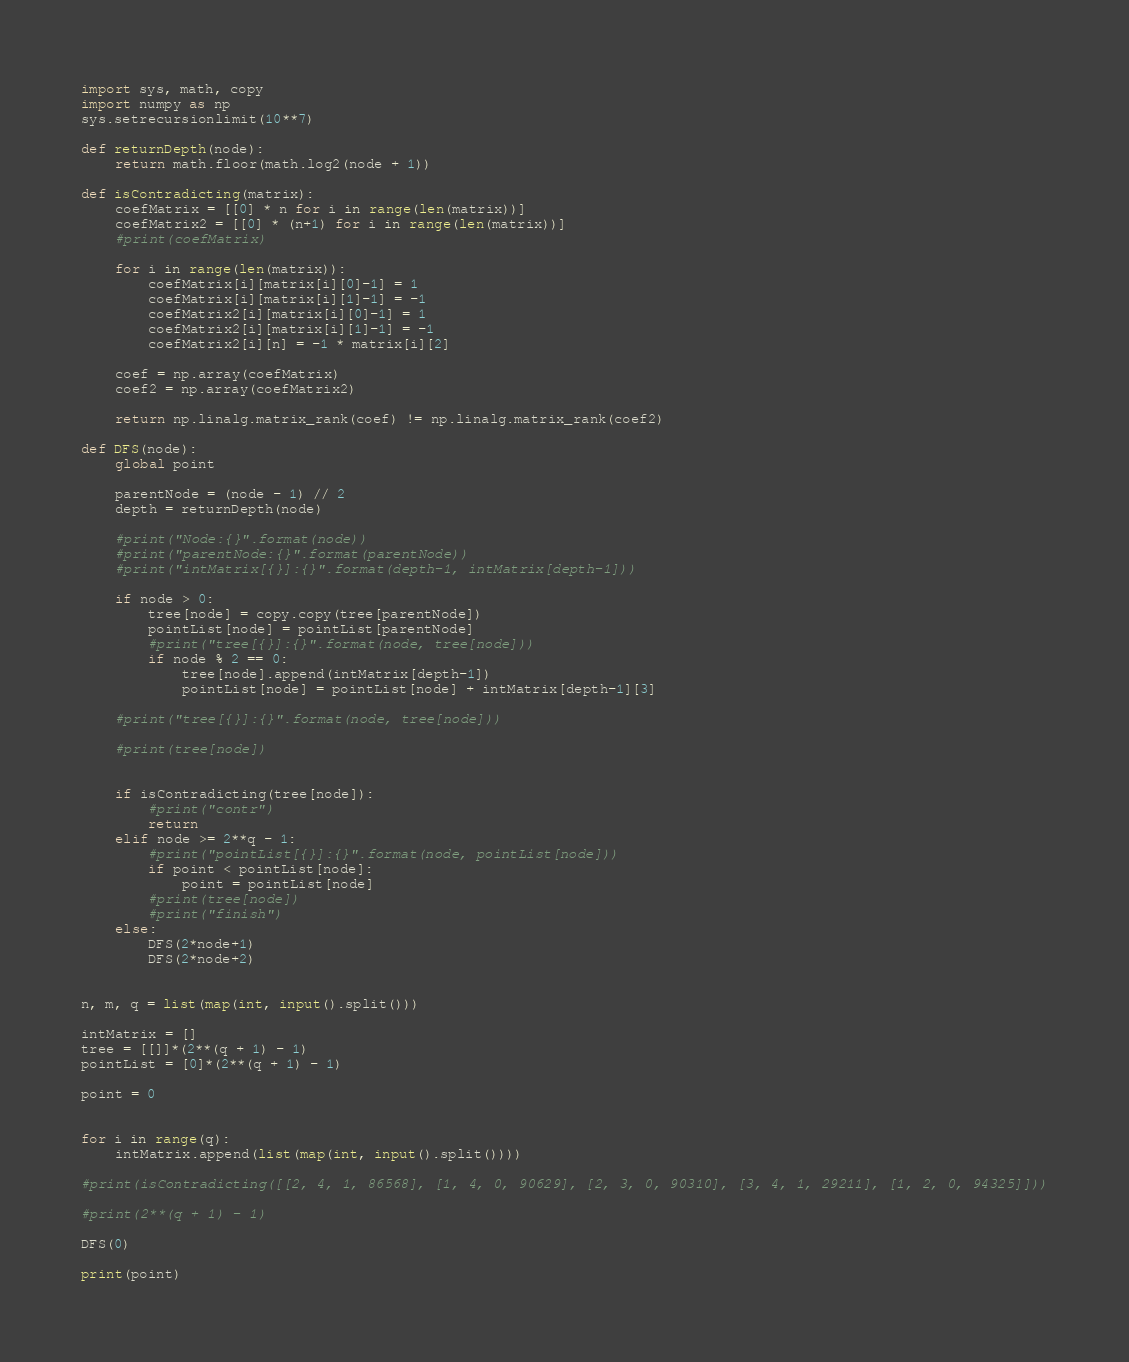Convert code to text. <code><loc_0><loc_0><loc_500><loc_500><_Python_>import sys, math, copy
import numpy as np
sys.setrecursionlimit(10**7)

def returnDepth(node):
    return math.floor(math.log2(node + 1))

def isContradicting(matrix):
    coefMatrix = [[0] * n for i in range(len(matrix))]
    coefMatrix2 = [[0] * (n+1) for i in range(len(matrix))]
    #print(coefMatrix)

    for i in range(len(matrix)):
        coefMatrix[i][matrix[i][0]-1] = 1
        coefMatrix[i][matrix[i][1]-1] = -1
        coefMatrix2[i][matrix[i][0]-1] = 1
        coefMatrix2[i][matrix[i][1]-1] = -1
        coefMatrix2[i][n] = -1 * matrix[i][2]
    
    coef = np.array(coefMatrix)
    coef2 = np.array(coefMatrix2)
    
    return np.linalg.matrix_rank(coef) != np.linalg.matrix_rank(coef2)
    
def DFS(node):
    global point

    parentNode = (node - 1) // 2
    depth = returnDepth(node)

    #print("Node:{}".format(node))
    #print("parentNode:{}".format(parentNode))
    #print("intMatrix[{}]:{}".format(depth-1, intMatrix[depth-1]))
    
    if node > 0:
        tree[node] = copy.copy(tree[parentNode])
        pointList[node] = pointList[parentNode]
        #print("tree[{}]:{}".format(node, tree[node]))
        if node % 2 == 0:
            tree[node].append(intMatrix[depth-1])
            pointList[node] = pointList[node] + intMatrix[depth-1][3]

    #print("tree[{}]:{}".format(node, tree[node]))

    #print(tree[node])
    

    if isContradicting(tree[node]):
        #print("contr")
        return
    elif node >= 2**q - 1:
        #print("pointList[{}]:{}".format(node, pointList[node]))
        if point < pointList[node]:
            point = pointList[node]
        #print(tree[node])
        #print("finish")
    else:
        DFS(2*node+1)
        DFS(2*node+2)
    

n, m, q = list(map(int, input().split()))

intMatrix = []
tree = [[]]*(2**(q + 1) - 1)
pointList = [0]*(2**(q + 1) - 1)

point = 0


for i in range(q):
    intMatrix.append(list(map(int, input().split())))

#print(isContradicting([[2, 4, 1, 86568], [1, 4, 0, 90629], [2, 3, 0, 90310], [3, 4, 1, 29211], [1, 2, 0, 94325]]))

#print(2**(q + 1) - 1)

DFS(0)

print(point)</code> 